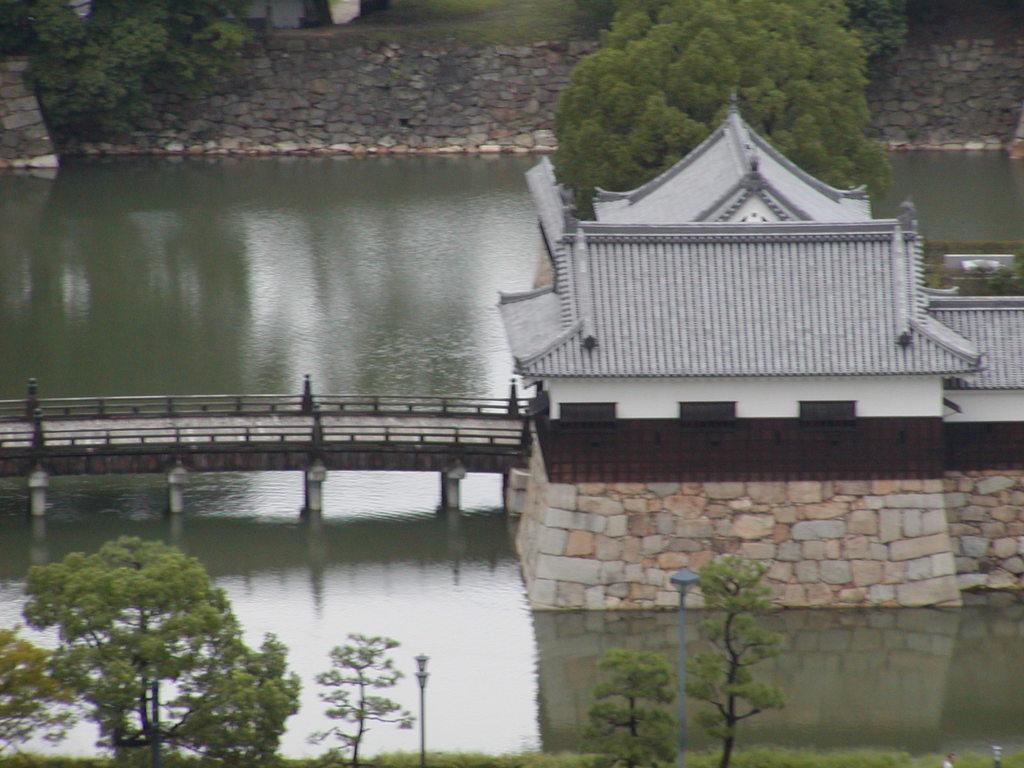How would you summarize this image in a sentence or two? In the background we can see wall, trees. In this picture we can see water, bridge and a house. 